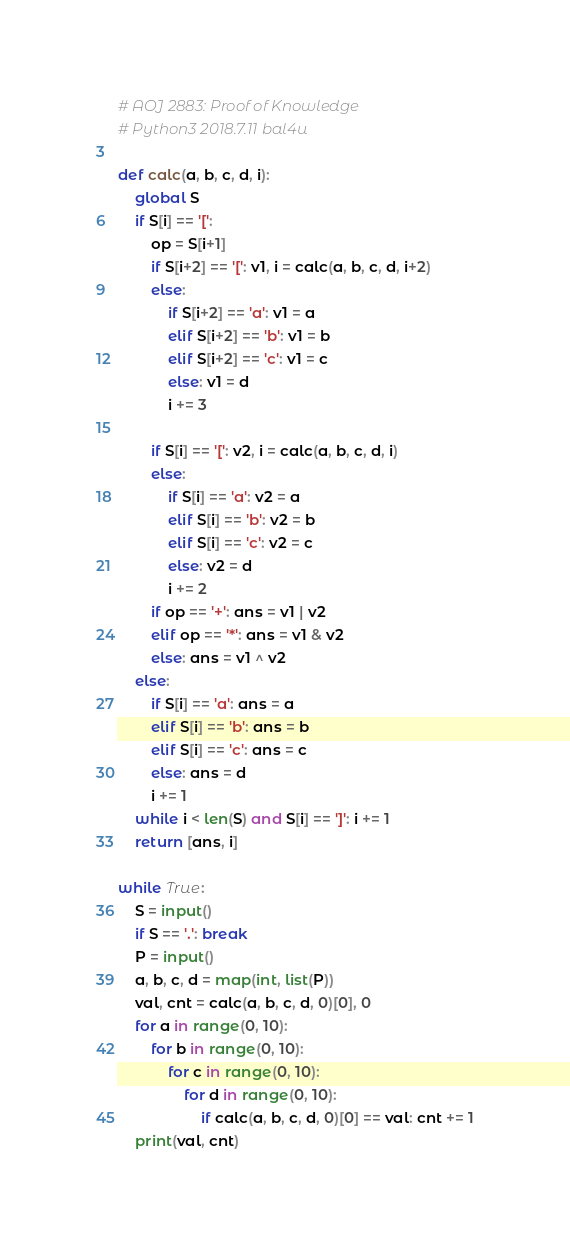Convert code to text. <code><loc_0><loc_0><loc_500><loc_500><_Python_># AOJ 2883: Proof of Knowledge
# Python3 2018.7.11 bal4u

def calc(a, b, c, d, i):
    global S
    if S[i] == '[':
        op = S[i+1]
        if S[i+2] == '[': v1, i = calc(a, b, c, d, i+2)
        else:
            if S[i+2] == 'a': v1 = a
            elif S[i+2] == 'b': v1 = b
            elif S[i+2] == 'c': v1 = c
            else: v1 = d
            i += 3

        if S[i] == '[': v2, i = calc(a, b, c, d, i)
        else:
            if S[i] == 'a': v2 = a
            elif S[i] == 'b': v2 = b
            elif S[i] == 'c': v2 = c
            else: v2 = d
            i += 2
        if op == '+': ans = v1 | v2
        elif op == '*': ans = v1 & v2
        else: ans = v1 ^ v2
    else:
        if S[i] == 'a': ans = a
        elif S[i] == 'b': ans = b
        elif S[i] == 'c': ans = c
        else: ans = d
        i += 1
    while i < len(S) and S[i] == ']': i += 1
    return [ans, i]

while True:
    S = input()
    if S == '.': break
    P = input()
    a, b, c, d = map(int, list(P))
    val, cnt = calc(a, b, c, d, 0)[0], 0
    for a in range(0, 10):
        for b in range(0, 10):
            for c in range(0, 10):
                for d in range(0, 10):
                    if calc(a, b, c, d, 0)[0] == val: cnt += 1
    print(val, cnt)

</code> 